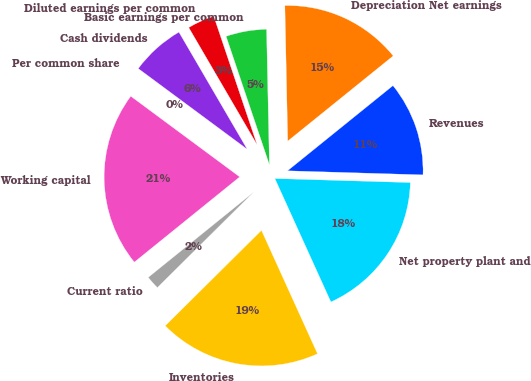Convert chart. <chart><loc_0><loc_0><loc_500><loc_500><pie_chart><fcel>Revenues<fcel>Depreciation Net earnings<fcel>Basic earnings per common<fcel>Diluted earnings per common<fcel>Cash dividends<fcel>Per common share<fcel>Working capital<fcel>Current ratio<fcel>Inventories<fcel>Net property plant and<nl><fcel>11.29%<fcel>14.52%<fcel>4.84%<fcel>3.23%<fcel>6.45%<fcel>0.0%<fcel>20.97%<fcel>1.61%<fcel>19.35%<fcel>17.74%<nl></chart> 